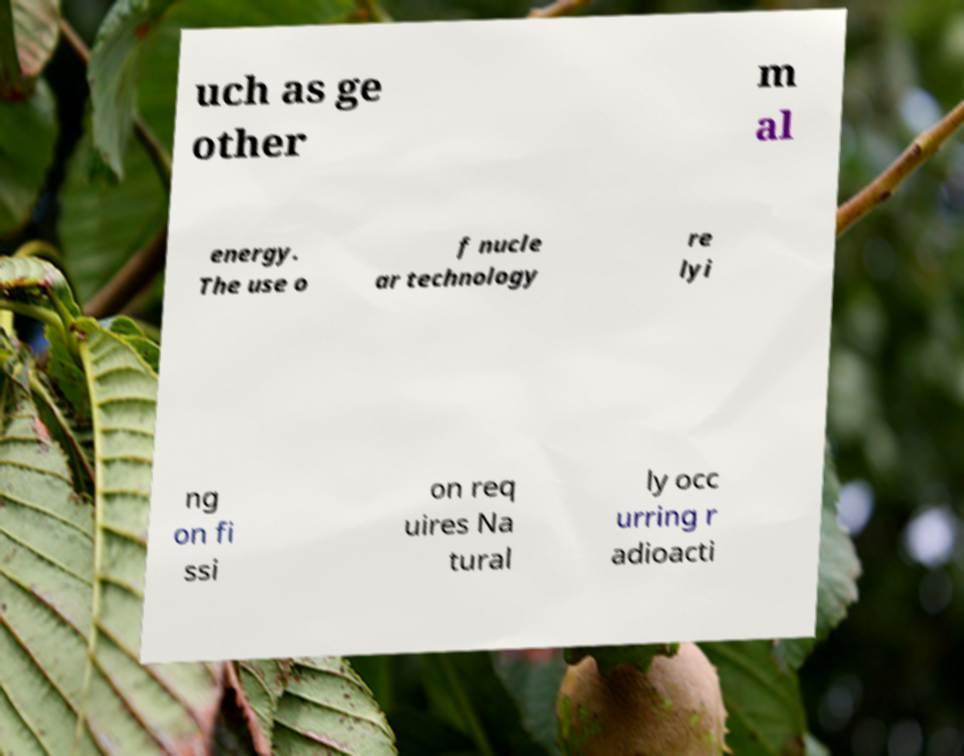Please identify and transcribe the text found in this image. uch as ge other m al energy. The use o f nucle ar technology re lyi ng on fi ssi on req uires Na tural ly occ urring r adioacti 